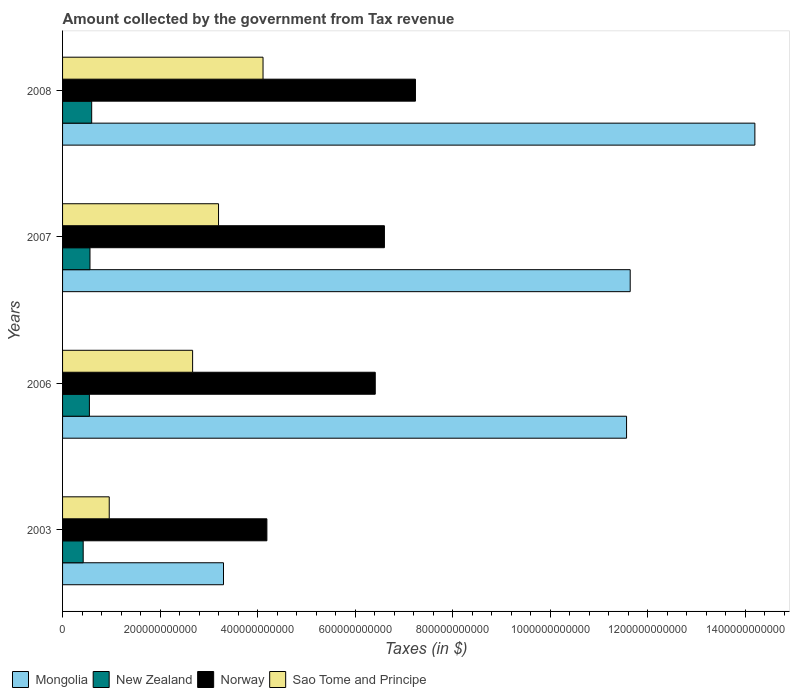How many different coloured bars are there?
Provide a succinct answer. 4. How many groups of bars are there?
Ensure brevity in your answer.  4. Are the number of bars per tick equal to the number of legend labels?
Ensure brevity in your answer.  Yes. Are the number of bars on each tick of the Y-axis equal?
Provide a succinct answer. Yes. How many bars are there on the 4th tick from the top?
Give a very brief answer. 4. What is the label of the 1st group of bars from the top?
Provide a succinct answer. 2008. What is the amount collected by the government from tax revenue in Norway in 2007?
Give a very brief answer. 6.60e+11. Across all years, what is the maximum amount collected by the government from tax revenue in Mongolia?
Your answer should be compact. 1.42e+12. Across all years, what is the minimum amount collected by the government from tax revenue in Norway?
Give a very brief answer. 4.19e+11. In which year was the amount collected by the government from tax revenue in New Zealand maximum?
Provide a succinct answer. 2008. In which year was the amount collected by the government from tax revenue in Sao Tome and Principe minimum?
Offer a very short reply. 2003. What is the total amount collected by the government from tax revenue in Sao Tome and Principe in the graph?
Your answer should be compact. 1.09e+12. What is the difference between the amount collected by the government from tax revenue in Norway in 2006 and that in 2007?
Your answer should be compact. -1.88e+1. What is the difference between the amount collected by the government from tax revenue in Mongolia in 2008 and the amount collected by the government from tax revenue in New Zealand in 2007?
Make the answer very short. 1.36e+12. What is the average amount collected by the government from tax revenue in Norway per year?
Give a very brief answer. 6.11e+11. In the year 2006, what is the difference between the amount collected by the government from tax revenue in Mongolia and amount collected by the government from tax revenue in Sao Tome and Principe?
Provide a short and direct response. 8.90e+11. In how many years, is the amount collected by the government from tax revenue in New Zealand greater than 800000000000 $?
Offer a terse response. 0. What is the ratio of the amount collected by the government from tax revenue in New Zealand in 2007 to that in 2008?
Offer a very short reply. 0.94. Is the amount collected by the government from tax revenue in New Zealand in 2006 less than that in 2008?
Provide a short and direct response. Yes. What is the difference between the highest and the second highest amount collected by the government from tax revenue in Mongolia?
Offer a terse response. 2.56e+11. What is the difference between the highest and the lowest amount collected by the government from tax revenue in Norway?
Provide a succinct answer. 3.05e+11. In how many years, is the amount collected by the government from tax revenue in New Zealand greater than the average amount collected by the government from tax revenue in New Zealand taken over all years?
Provide a short and direct response. 3. Is the sum of the amount collected by the government from tax revenue in Mongolia in 2003 and 2006 greater than the maximum amount collected by the government from tax revenue in New Zealand across all years?
Keep it short and to the point. Yes. Is it the case that in every year, the sum of the amount collected by the government from tax revenue in Mongolia and amount collected by the government from tax revenue in Norway is greater than the sum of amount collected by the government from tax revenue in Sao Tome and Principe and amount collected by the government from tax revenue in New Zealand?
Your response must be concise. Yes. Is it the case that in every year, the sum of the amount collected by the government from tax revenue in Sao Tome and Principe and amount collected by the government from tax revenue in New Zealand is greater than the amount collected by the government from tax revenue in Norway?
Offer a very short reply. No. How many years are there in the graph?
Make the answer very short. 4. What is the difference between two consecutive major ticks on the X-axis?
Make the answer very short. 2.00e+11. Does the graph contain grids?
Keep it short and to the point. No. What is the title of the graph?
Provide a succinct answer. Amount collected by the government from Tax revenue. What is the label or title of the X-axis?
Your answer should be compact. Taxes (in $). What is the Taxes (in $) of Mongolia in 2003?
Your response must be concise. 3.30e+11. What is the Taxes (in $) of New Zealand in 2003?
Offer a very short reply. 4.23e+1. What is the Taxes (in $) of Norway in 2003?
Your answer should be very brief. 4.19e+11. What is the Taxes (in $) in Sao Tome and Principe in 2003?
Keep it short and to the point. 9.57e+1. What is the Taxes (in $) of Mongolia in 2006?
Offer a terse response. 1.16e+12. What is the Taxes (in $) of New Zealand in 2006?
Your response must be concise. 5.50e+1. What is the Taxes (in $) of Norway in 2006?
Ensure brevity in your answer.  6.41e+11. What is the Taxes (in $) in Sao Tome and Principe in 2006?
Provide a short and direct response. 2.67e+11. What is the Taxes (in $) of Mongolia in 2007?
Give a very brief answer. 1.16e+12. What is the Taxes (in $) in New Zealand in 2007?
Your answer should be compact. 5.62e+1. What is the Taxes (in $) in Norway in 2007?
Keep it short and to the point. 6.60e+11. What is the Taxes (in $) of Sao Tome and Principe in 2007?
Offer a very short reply. 3.20e+11. What is the Taxes (in $) of Mongolia in 2008?
Ensure brevity in your answer.  1.42e+12. What is the Taxes (in $) in New Zealand in 2008?
Give a very brief answer. 5.97e+1. What is the Taxes (in $) in Norway in 2008?
Provide a succinct answer. 7.24e+11. What is the Taxes (in $) in Sao Tome and Principe in 2008?
Your response must be concise. 4.11e+11. Across all years, what is the maximum Taxes (in $) in Mongolia?
Your answer should be very brief. 1.42e+12. Across all years, what is the maximum Taxes (in $) of New Zealand?
Keep it short and to the point. 5.97e+1. Across all years, what is the maximum Taxes (in $) of Norway?
Offer a terse response. 7.24e+11. Across all years, what is the maximum Taxes (in $) in Sao Tome and Principe?
Offer a very short reply. 4.11e+11. Across all years, what is the minimum Taxes (in $) in Mongolia?
Your response must be concise. 3.30e+11. Across all years, what is the minimum Taxes (in $) in New Zealand?
Give a very brief answer. 4.23e+1. Across all years, what is the minimum Taxes (in $) in Norway?
Your answer should be very brief. 4.19e+11. Across all years, what is the minimum Taxes (in $) in Sao Tome and Principe?
Keep it short and to the point. 9.57e+1. What is the total Taxes (in $) in Mongolia in the graph?
Ensure brevity in your answer.  4.07e+12. What is the total Taxes (in $) in New Zealand in the graph?
Offer a very short reply. 2.13e+11. What is the total Taxes (in $) in Norway in the graph?
Provide a succinct answer. 2.44e+12. What is the total Taxes (in $) of Sao Tome and Principe in the graph?
Offer a very short reply. 1.09e+12. What is the difference between the Taxes (in $) in Mongolia in 2003 and that in 2006?
Make the answer very short. -8.26e+11. What is the difference between the Taxes (in $) of New Zealand in 2003 and that in 2006?
Give a very brief answer. -1.28e+1. What is the difference between the Taxes (in $) of Norway in 2003 and that in 2006?
Your answer should be very brief. -2.22e+11. What is the difference between the Taxes (in $) of Sao Tome and Principe in 2003 and that in 2006?
Your answer should be very brief. -1.71e+11. What is the difference between the Taxes (in $) of Mongolia in 2003 and that in 2007?
Your answer should be compact. -8.34e+11. What is the difference between the Taxes (in $) of New Zealand in 2003 and that in 2007?
Provide a succinct answer. -1.39e+1. What is the difference between the Taxes (in $) in Norway in 2003 and that in 2007?
Offer a very short reply. -2.41e+11. What is the difference between the Taxes (in $) of Sao Tome and Principe in 2003 and that in 2007?
Give a very brief answer. -2.24e+11. What is the difference between the Taxes (in $) in Mongolia in 2003 and that in 2008?
Offer a very short reply. -1.09e+12. What is the difference between the Taxes (in $) of New Zealand in 2003 and that in 2008?
Make the answer very short. -1.74e+1. What is the difference between the Taxes (in $) of Norway in 2003 and that in 2008?
Give a very brief answer. -3.05e+11. What is the difference between the Taxes (in $) of Sao Tome and Principe in 2003 and that in 2008?
Your answer should be very brief. -3.15e+11. What is the difference between the Taxes (in $) of Mongolia in 2006 and that in 2007?
Your answer should be compact. -7.47e+09. What is the difference between the Taxes (in $) of New Zealand in 2006 and that in 2007?
Make the answer very short. -1.19e+09. What is the difference between the Taxes (in $) in Norway in 2006 and that in 2007?
Your response must be concise. -1.88e+1. What is the difference between the Taxes (in $) in Sao Tome and Principe in 2006 and that in 2007?
Make the answer very short. -5.32e+1. What is the difference between the Taxes (in $) in Mongolia in 2006 and that in 2008?
Provide a short and direct response. -2.63e+11. What is the difference between the Taxes (in $) in New Zealand in 2006 and that in 2008?
Provide a short and direct response. -4.69e+09. What is the difference between the Taxes (in $) in Norway in 2006 and that in 2008?
Provide a short and direct response. -8.24e+1. What is the difference between the Taxes (in $) of Sao Tome and Principe in 2006 and that in 2008?
Your answer should be compact. -1.44e+11. What is the difference between the Taxes (in $) of Mongolia in 2007 and that in 2008?
Offer a terse response. -2.56e+11. What is the difference between the Taxes (in $) of New Zealand in 2007 and that in 2008?
Make the answer very short. -3.50e+09. What is the difference between the Taxes (in $) of Norway in 2007 and that in 2008?
Offer a terse response. -6.36e+1. What is the difference between the Taxes (in $) of Sao Tome and Principe in 2007 and that in 2008?
Give a very brief answer. -9.12e+1. What is the difference between the Taxes (in $) of Mongolia in 2003 and the Taxes (in $) of New Zealand in 2006?
Ensure brevity in your answer.  2.75e+11. What is the difference between the Taxes (in $) in Mongolia in 2003 and the Taxes (in $) in Norway in 2006?
Your response must be concise. -3.11e+11. What is the difference between the Taxes (in $) in Mongolia in 2003 and the Taxes (in $) in Sao Tome and Principe in 2006?
Make the answer very short. 6.33e+1. What is the difference between the Taxes (in $) of New Zealand in 2003 and the Taxes (in $) of Norway in 2006?
Your answer should be compact. -5.99e+11. What is the difference between the Taxes (in $) of New Zealand in 2003 and the Taxes (in $) of Sao Tome and Principe in 2006?
Offer a very short reply. -2.24e+11. What is the difference between the Taxes (in $) in Norway in 2003 and the Taxes (in $) in Sao Tome and Principe in 2006?
Provide a succinct answer. 1.52e+11. What is the difference between the Taxes (in $) of Mongolia in 2003 and the Taxes (in $) of New Zealand in 2007?
Your answer should be very brief. 2.74e+11. What is the difference between the Taxes (in $) in Mongolia in 2003 and the Taxes (in $) in Norway in 2007?
Provide a succinct answer. -3.30e+11. What is the difference between the Taxes (in $) in Mongolia in 2003 and the Taxes (in $) in Sao Tome and Principe in 2007?
Ensure brevity in your answer.  1.02e+1. What is the difference between the Taxes (in $) in New Zealand in 2003 and the Taxes (in $) in Norway in 2007?
Offer a terse response. -6.18e+11. What is the difference between the Taxes (in $) of New Zealand in 2003 and the Taxes (in $) of Sao Tome and Principe in 2007?
Offer a very short reply. -2.78e+11. What is the difference between the Taxes (in $) in Norway in 2003 and the Taxes (in $) in Sao Tome and Principe in 2007?
Keep it short and to the point. 9.91e+1. What is the difference between the Taxes (in $) of Mongolia in 2003 and the Taxes (in $) of New Zealand in 2008?
Make the answer very short. 2.70e+11. What is the difference between the Taxes (in $) in Mongolia in 2003 and the Taxes (in $) in Norway in 2008?
Offer a very short reply. -3.94e+11. What is the difference between the Taxes (in $) in Mongolia in 2003 and the Taxes (in $) in Sao Tome and Principe in 2008?
Provide a short and direct response. -8.11e+1. What is the difference between the Taxes (in $) in New Zealand in 2003 and the Taxes (in $) in Norway in 2008?
Your response must be concise. -6.81e+11. What is the difference between the Taxes (in $) of New Zealand in 2003 and the Taxes (in $) of Sao Tome and Principe in 2008?
Offer a terse response. -3.69e+11. What is the difference between the Taxes (in $) in Norway in 2003 and the Taxes (in $) in Sao Tome and Principe in 2008?
Make the answer very short. 7.89e+09. What is the difference between the Taxes (in $) of Mongolia in 2006 and the Taxes (in $) of New Zealand in 2007?
Your answer should be compact. 1.10e+12. What is the difference between the Taxes (in $) of Mongolia in 2006 and the Taxes (in $) of Norway in 2007?
Your answer should be compact. 4.96e+11. What is the difference between the Taxes (in $) of Mongolia in 2006 and the Taxes (in $) of Sao Tome and Principe in 2007?
Provide a succinct answer. 8.37e+11. What is the difference between the Taxes (in $) of New Zealand in 2006 and the Taxes (in $) of Norway in 2007?
Provide a succinct answer. -6.05e+11. What is the difference between the Taxes (in $) of New Zealand in 2006 and the Taxes (in $) of Sao Tome and Principe in 2007?
Provide a succinct answer. -2.65e+11. What is the difference between the Taxes (in $) in Norway in 2006 and the Taxes (in $) in Sao Tome and Principe in 2007?
Keep it short and to the point. 3.21e+11. What is the difference between the Taxes (in $) in Mongolia in 2006 and the Taxes (in $) in New Zealand in 2008?
Provide a succinct answer. 1.10e+12. What is the difference between the Taxes (in $) in Mongolia in 2006 and the Taxes (in $) in Norway in 2008?
Ensure brevity in your answer.  4.33e+11. What is the difference between the Taxes (in $) of Mongolia in 2006 and the Taxes (in $) of Sao Tome and Principe in 2008?
Keep it short and to the point. 7.45e+11. What is the difference between the Taxes (in $) in New Zealand in 2006 and the Taxes (in $) in Norway in 2008?
Provide a short and direct response. -6.68e+11. What is the difference between the Taxes (in $) in New Zealand in 2006 and the Taxes (in $) in Sao Tome and Principe in 2008?
Your answer should be compact. -3.56e+11. What is the difference between the Taxes (in $) in Norway in 2006 and the Taxes (in $) in Sao Tome and Principe in 2008?
Keep it short and to the point. 2.30e+11. What is the difference between the Taxes (in $) in Mongolia in 2007 and the Taxes (in $) in New Zealand in 2008?
Your response must be concise. 1.10e+12. What is the difference between the Taxes (in $) in Mongolia in 2007 and the Taxes (in $) in Norway in 2008?
Provide a succinct answer. 4.40e+11. What is the difference between the Taxes (in $) of Mongolia in 2007 and the Taxes (in $) of Sao Tome and Principe in 2008?
Your answer should be very brief. 7.53e+11. What is the difference between the Taxes (in $) of New Zealand in 2007 and the Taxes (in $) of Norway in 2008?
Ensure brevity in your answer.  -6.67e+11. What is the difference between the Taxes (in $) in New Zealand in 2007 and the Taxes (in $) in Sao Tome and Principe in 2008?
Provide a short and direct response. -3.55e+11. What is the difference between the Taxes (in $) of Norway in 2007 and the Taxes (in $) of Sao Tome and Principe in 2008?
Your response must be concise. 2.49e+11. What is the average Taxes (in $) of Mongolia per year?
Your response must be concise. 1.02e+12. What is the average Taxes (in $) of New Zealand per year?
Make the answer very short. 5.33e+1. What is the average Taxes (in $) in Norway per year?
Your answer should be very brief. 6.11e+11. What is the average Taxes (in $) in Sao Tome and Principe per year?
Offer a terse response. 2.73e+11. In the year 2003, what is the difference between the Taxes (in $) of Mongolia and Taxes (in $) of New Zealand?
Ensure brevity in your answer.  2.88e+11. In the year 2003, what is the difference between the Taxes (in $) of Mongolia and Taxes (in $) of Norway?
Your answer should be very brief. -8.90e+1. In the year 2003, what is the difference between the Taxes (in $) of Mongolia and Taxes (in $) of Sao Tome and Principe?
Keep it short and to the point. 2.34e+11. In the year 2003, what is the difference between the Taxes (in $) in New Zealand and Taxes (in $) in Norway?
Ensure brevity in your answer.  -3.77e+11. In the year 2003, what is the difference between the Taxes (in $) in New Zealand and Taxes (in $) in Sao Tome and Principe?
Ensure brevity in your answer.  -5.34e+1. In the year 2003, what is the difference between the Taxes (in $) of Norway and Taxes (in $) of Sao Tome and Principe?
Provide a short and direct response. 3.23e+11. In the year 2006, what is the difference between the Taxes (in $) in Mongolia and Taxes (in $) in New Zealand?
Your response must be concise. 1.10e+12. In the year 2006, what is the difference between the Taxes (in $) in Mongolia and Taxes (in $) in Norway?
Make the answer very short. 5.15e+11. In the year 2006, what is the difference between the Taxes (in $) of Mongolia and Taxes (in $) of Sao Tome and Principe?
Keep it short and to the point. 8.90e+11. In the year 2006, what is the difference between the Taxes (in $) of New Zealand and Taxes (in $) of Norway?
Offer a terse response. -5.86e+11. In the year 2006, what is the difference between the Taxes (in $) in New Zealand and Taxes (in $) in Sao Tome and Principe?
Your answer should be compact. -2.12e+11. In the year 2006, what is the difference between the Taxes (in $) in Norway and Taxes (in $) in Sao Tome and Principe?
Your answer should be compact. 3.74e+11. In the year 2007, what is the difference between the Taxes (in $) in Mongolia and Taxes (in $) in New Zealand?
Your response must be concise. 1.11e+12. In the year 2007, what is the difference between the Taxes (in $) of Mongolia and Taxes (in $) of Norway?
Give a very brief answer. 5.04e+11. In the year 2007, what is the difference between the Taxes (in $) in Mongolia and Taxes (in $) in Sao Tome and Principe?
Offer a very short reply. 8.44e+11. In the year 2007, what is the difference between the Taxes (in $) in New Zealand and Taxes (in $) in Norway?
Give a very brief answer. -6.04e+11. In the year 2007, what is the difference between the Taxes (in $) in New Zealand and Taxes (in $) in Sao Tome and Principe?
Your answer should be compact. -2.64e+11. In the year 2007, what is the difference between the Taxes (in $) in Norway and Taxes (in $) in Sao Tome and Principe?
Your answer should be compact. 3.40e+11. In the year 2008, what is the difference between the Taxes (in $) in Mongolia and Taxes (in $) in New Zealand?
Ensure brevity in your answer.  1.36e+12. In the year 2008, what is the difference between the Taxes (in $) in Mongolia and Taxes (in $) in Norway?
Keep it short and to the point. 6.96e+11. In the year 2008, what is the difference between the Taxes (in $) of Mongolia and Taxes (in $) of Sao Tome and Principe?
Offer a very short reply. 1.01e+12. In the year 2008, what is the difference between the Taxes (in $) of New Zealand and Taxes (in $) of Norway?
Provide a succinct answer. -6.64e+11. In the year 2008, what is the difference between the Taxes (in $) of New Zealand and Taxes (in $) of Sao Tome and Principe?
Ensure brevity in your answer.  -3.51e+11. In the year 2008, what is the difference between the Taxes (in $) in Norway and Taxes (in $) in Sao Tome and Principe?
Offer a terse response. 3.13e+11. What is the ratio of the Taxes (in $) in Mongolia in 2003 to that in 2006?
Your answer should be very brief. 0.29. What is the ratio of the Taxes (in $) of New Zealand in 2003 to that in 2006?
Keep it short and to the point. 0.77. What is the ratio of the Taxes (in $) of Norway in 2003 to that in 2006?
Offer a very short reply. 0.65. What is the ratio of the Taxes (in $) in Sao Tome and Principe in 2003 to that in 2006?
Provide a succinct answer. 0.36. What is the ratio of the Taxes (in $) of Mongolia in 2003 to that in 2007?
Your response must be concise. 0.28. What is the ratio of the Taxes (in $) in New Zealand in 2003 to that in 2007?
Your answer should be compact. 0.75. What is the ratio of the Taxes (in $) of Norway in 2003 to that in 2007?
Your answer should be very brief. 0.63. What is the ratio of the Taxes (in $) in Sao Tome and Principe in 2003 to that in 2007?
Offer a very short reply. 0.3. What is the ratio of the Taxes (in $) in Mongolia in 2003 to that in 2008?
Your answer should be compact. 0.23. What is the ratio of the Taxes (in $) of New Zealand in 2003 to that in 2008?
Provide a succinct answer. 0.71. What is the ratio of the Taxes (in $) of Norway in 2003 to that in 2008?
Offer a very short reply. 0.58. What is the ratio of the Taxes (in $) of Sao Tome and Principe in 2003 to that in 2008?
Offer a very short reply. 0.23. What is the ratio of the Taxes (in $) in Mongolia in 2006 to that in 2007?
Your answer should be compact. 0.99. What is the ratio of the Taxes (in $) in New Zealand in 2006 to that in 2007?
Your response must be concise. 0.98. What is the ratio of the Taxes (in $) in Norway in 2006 to that in 2007?
Give a very brief answer. 0.97. What is the ratio of the Taxes (in $) of Sao Tome and Principe in 2006 to that in 2007?
Offer a terse response. 0.83. What is the ratio of the Taxes (in $) of Mongolia in 2006 to that in 2008?
Provide a succinct answer. 0.81. What is the ratio of the Taxes (in $) in New Zealand in 2006 to that in 2008?
Ensure brevity in your answer.  0.92. What is the ratio of the Taxes (in $) of Norway in 2006 to that in 2008?
Offer a very short reply. 0.89. What is the ratio of the Taxes (in $) in Sao Tome and Principe in 2006 to that in 2008?
Make the answer very short. 0.65. What is the ratio of the Taxes (in $) of Mongolia in 2007 to that in 2008?
Your response must be concise. 0.82. What is the ratio of the Taxes (in $) of New Zealand in 2007 to that in 2008?
Your response must be concise. 0.94. What is the ratio of the Taxes (in $) in Norway in 2007 to that in 2008?
Your response must be concise. 0.91. What is the ratio of the Taxes (in $) in Sao Tome and Principe in 2007 to that in 2008?
Your answer should be very brief. 0.78. What is the difference between the highest and the second highest Taxes (in $) of Mongolia?
Ensure brevity in your answer.  2.56e+11. What is the difference between the highest and the second highest Taxes (in $) of New Zealand?
Provide a succinct answer. 3.50e+09. What is the difference between the highest and the second highest Taxes (in $) of Norway?
Keep it short and to the point. 6.36e+1. What is the difference between the highest and the second highest Taxes (in $) of Sao Tome and Principe?
Offer a very short reply. 9.12e+1. What is the difference between the highest and the lowest Taxes (in $) of Mongolia?
Keep it short and to the point. 1.09e+12. What is the difference between the highest and the lowest Taxes (in $) of New Zealand?
Ensure brevity in your answer.  1.74e+1. What is the difference between the highest and the lowest Taxes (in $) of Norway?
Your answer should be compact. 3.05e+11. What is the difference between the highest and the lowest Taxes (in $) in Sao Tome and Principe?
Offer a very short reply. 3.15e+11. 